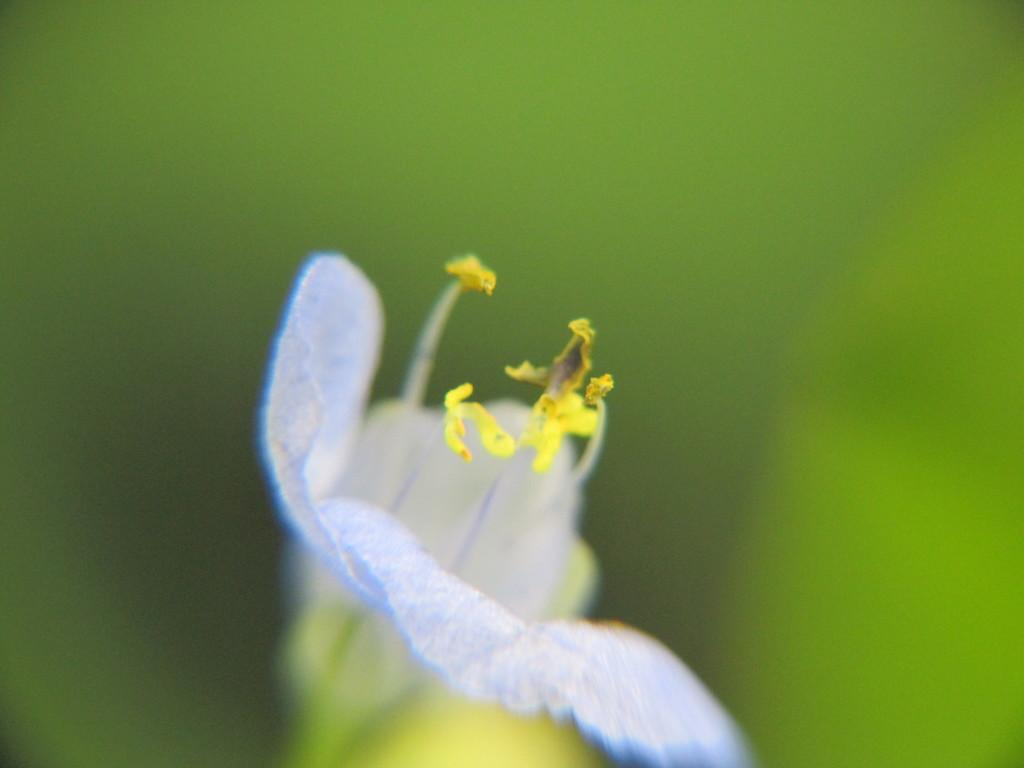What is the main subject of the image? There is a flower in the image. Can you describe the background of the image? The background of the image is blurred. What type of pleasure can be seen enjoying the cow in the image? There is no cow or pleasure present in the image; it features a flower with a blurred background. 